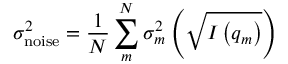<formula> <loc_0><loc_0><loc_500><loc_500>\sigma _ { n o i s e } ^ { 2 } = \frac { 1 } { N } \sum _ { m } ^ { N } \sigma _ { m } ^ { 2 } \left ( \sqrt { I \left ( q _ { m } \right ) } \right )</formula> 